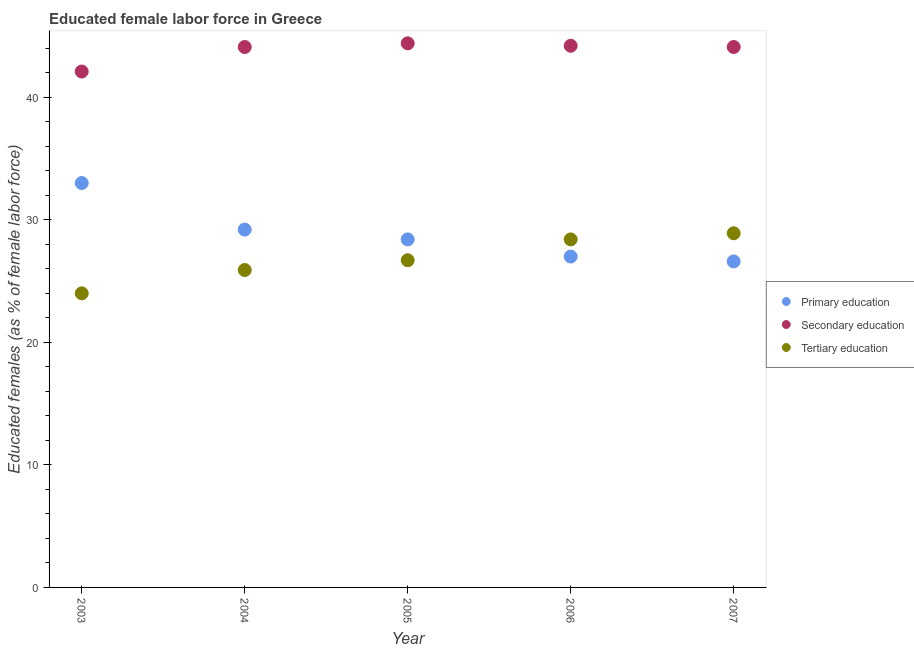How many different coloured dotlines are there?
Provide a succinct answer. 3. Is the number of dotlines equal to the number of legend labels?
Your answer should be very brief. Yes. What is the percentage of female labor force who received tertiary education in 2006?
Your answer should be compact. 28.4. Across all years, what is the maximum percentage of female labor force who received tertiary education?
Your answer should be very brief. 28.9. In which year was the percentage of female labor force who received secondary education maximum?
Offer a terse response. 2005. What is the total percentage of female labor force who received primary education in the graph?
Provide a succinct answer. 144.2. What is the difference between the percentage of female labor force who received primary education in 2003 and that in 2007?
Give a very brief answer. 6.4. What is the difference between the percentage of female labor force who received primary education in 2003 and the percentage of female labor force who received secondary education in 2005?
Provide a succinct answer. -11.4. What is the average percentage of female labor force who received tertiary education per year?
Make the answer very short. 26.78. In the year 2004, what is the difference between the percentage of female labor force who received secondary education and percentage of female labor force who received primary education?
Keep it short and to the point. 14.9. In how many years, is the percentage of female labor force who received tertiary education greater than 20 %?
Your answer should be compact. 5. What is the ratio of the percentage of female labor force who received tertiary education in 2003 to that in 2004?
Give a very brief answer. 0.93. Is the percentage of female labor force who received primary education in 2003 less than that in 2007?
Provide a succinct answer. No. What is the difference between the highest and the second highest percentage of female labor force who received primary education?
Offer a very short reply. 3.8. What is the difference between the highest and the lowest percentage of female labor force who received tertiary education?
Provide a short and direct response. 4.9. In how many years, is the percentage of female labor force who received secondary education greater than the average percentage of female labor force who received secondary education taken over all years?
Provide a short and direct response. 4. Is the sum of the percentage of female labor force who received tertiary education in 2005 and 2007 greater than the maximum percentage of female labor force who received primary education across all years?
Your response must be concise. Yes. Is it the case that in every year, the sum of the percentage of female labor force who received primary education and percentage of female labor force who received secondary education is greater than the percentage of female labor force who received tertiary education?
Give a very brief answer. Yes. Is the percentage of female labor force who received tertiary education strictly greater than the percentage of female labor force who received primary education over the years?
Keep it short and to the point. No. Is the percentage of female labor force who received primary education strictly less than the percentage of female labor force who received secondary education over the years?
Provide a succinct answer. Yes. What is the difference between two consecutive major ticks on the Y-axis?
Make the answer very short. 10. Does the graph contain any zero values?
Provide a short and direct response. No. Does the graph contain grids?
Your answer should be compact. No. Where does the legend appear in the graph?
Offer a very short reply. Center right. How many legend labels are there?
Make the answer very short. 3. What is the title of the graph?
Offer a very short reply. Educated female labor force in Greece. Does "Profit Tax" appear as one of the legend labels in the graph?
Give a very brief answer. No. What is the label or title of the Y-axis?
Make the answer very short. Educated females (as % of female labor force). What is the Educated females (as % of female labor force) of Primary education in 2003?
Your answer should be compact. 33. What is the Educated females (as % of female labor force) of Secondary education in 2003?
Provide a short and direct response. 42.1. What is the Educated females (as % of female labor force) of Tertiary education in 2003?
Offer a terse response. 24. What is the Educated females (as % of female labor force) of Primary education in 2004?
Your answer should be very brief. 29.2. What is the Educated females (as % of female labor force) in Secondary education in 2004?
Keep it short and to the point. 44.1. What is the Educated females (as % of female labor force) of Tertiary education in 2004?
Provide a short and direct response. 25.9. What is the Educated females (as % of female labor force) in Primary education in 2005?
Provide a short and direct response. 28.4. What is the Educated females (as % of female labor force) of Secondary education in 2005?
Provide a short and direct response. 44.4. What is the Educated females (as % of female labor force) of Tertiary education in 2005?
Keep it short and to the point. 26.7. What is the Educated females (as % of female labor force) of Primary education in 2006?
Your response must be concise. 27. What is the Educated females (as % of female labor force) of Secondary education in 2006?
Ensure brevity in your answer.  44.2. What is the Educated females (as % of female labor force) in Tertiary education in 2006?
Provide a succinct answer. 28.4. What is the Educated females (as % of female labor force) in Primary education in 2007?
Your response must be concise. 26.6. What is the Educated females (as % of female labor force) of Secondary education in 2007?
Your answer should be very brief. 44.1. What is the Educated females (as % of female labor force) in Tertiary education in 2007?
Give a very brief answer. 28.9. Across all years, what is the maximum Educated females (as % of female labor force) in Secondary education?
Provide a short and direct response. 44.4. Across all years, what is the maximum Educated females (as % of female labor force) in Tertiary education?
Your response must be concise. 28.9. Across all years, what is the minimum Educated females (as % of female labor force) of Primary education?
Offer a very short reply. 26.6. Across all years, what is the minimum Educated females (as % of female labor force) of Secondary education?
Provide a short and direct response. 42.1. Across all years, what is the minimum Educated females (as % of female labor force) of Tertiary education?
Offer a terse response. 24. What is the total Educated females (as % of female labor force) of Primary education in the graph?
Provide a succinct answer. 144.2. What is the total Educated females (as % of female labor force) of Secondary education in the graph?
Give a very brief answer. 218.9. What is the total Educated females (as % of female labor force) of Tertiary education in the graph?
Keep it short and to the point. 133.9. What is the difference between the Educated females (as % of female labor force) in Primary education in 2003 and that in 2004?
Provide a short and direct response. 3.8. What is the difference between the Educated females (as % of female labor force) in Secondary education in 2003 and that in 2004?
Your response must be concise. -2. What is the difference between the Educated females (as % of female labor force) in Tertiary education in 2003 and that in 2004?
Offer a very short reply. -1.9. What is the difference between the Educated females (as % of female labor force) of Primary education in 2003 and that in 2005?
Ensure brevity in your answer.  4.6. What is the difference between the Educated females (as % of female labor force) of Tertiary education in 2003 and that in 2005?
Provide a succinct answer. -2.7. What is the difference between the Educated females (as % of female labor force) in Secondary education in 2003 and that in 2006?
Your response must be concise. -2.1. What is the difference between the Educated females (as % of female labor force) in Tertiary education in 2003 and that in 2006?
Keep it short and to the point. -4.4. What is the difference between the Educated females (as % of female labor force) in Tertiary education in 2003 and that in 2007?
Make the answer very short. -4.9. What is the difference between the Educated females (as % of female labor force) in Primary education in 2004 and that in 2005?
Give a very brief answer. 0.8. What is the difference between the Educated females (as % of female labor force) of Tertiary education in 2004 and that in 2005?
Make the answer very short. -0.8. What is the difference between the Educated females (as % of female labor force) of Primary education in 2004 and that in 2006?
Make the answer very short. 2.2. What is the difference between the Educated females (as % of female labor force) in Secondary education in 2004 and that in 2006?
Give a very brief answer. -0.1. What is the difference between the Educated females (as % of female labor force) in Tertiary education in 2004 and that in 2007?
Keep it short and to the point. -3. What is the difference between the Educated females (as % of female labor force) of Secondary education in 2005 and that in 2006?
Give a very brief answer. 0.2. What is the difference between the Educated females (as % of female labor force) of Primary education in 2005 and that in 2007?
Your response must be concise. 1.8. What is the difference between the Educated females (as % of female labor force) of Secondary education in 2006 and that in 2007?
Keep it short and to the point. 0.1. What is the difference between the Educated females (as % of female labor force) in Tertiary education in 2006 and that in 2007?
Give a very brief answer. -0.5. What is the difference between the Educated females (as % of female labor force) of Primary education in 2003 and the Educated females (as % of female labor force) of Secondary education in 2004?
Provide a short and direct response. -11.1. What is the difference between the Educated females (as % of female labor force) of Secondary education in 2003 and the Educated females (as % of female labor force) of Tertiary education in 2004?
Make the answer very short. 16.2. What is the difference between the Educated females (as % of female labor force) of Primary education in 2003 and the Educated females (as % of female labor force) of Secondary education in 2005?
Provide a succinct answer. -11.4. What is the difference between the Educated females (as % of female labor force) in Primary education in 2003 and the Educated females (as % of female labor force) in Tertiary education in 2005?
Provide a short and direct response. 6.3. What is the difference between the Educated females (as % of female labor force) of Secondary education in 2003 and the Educated females (as % of female labor force) of Tertiary education in 2005?
Offer a very short reply. 15.4. What is the difference between the Educated females (as % of female labor force) in Primary education in 2003 and the Educated females (as % of female labor force) in Secondary education in 2006?
Your answer should be very brief. -11.2. What is the difference between the Educated females (as % of female labor force) in Primary education in 2003 and the Educated females (as % of female labor force) in Tertiary education in 2006?
Offer a terse response. 4.6. What is the difference between the Educated females (as % of female labor force) of Secondary education in 2003 and the Educated females (as % of female labor force) of Tertiary education in 2006?
Keep it short and to the point. 13.7. What is the difference between the Educated females (as % of female labor force) in Primary education in 2003 and the Educated females (as % of female labor force) in Tertiary education in 2007?
Your answer should be very brief. 4.1. What is the difference between the Educated females (as % of female labor force) of Primary education in 2004 and the Educated females (as % of female labor force) of Secondary education in 2005?
Provide a short and direct response. -15.2. What is the difference between the Educated females (as % of female labor force) in Primary education in 2004 and the Educated females (as % of female labor force) in Tertiary education in 2005?
Keep it short and to the point. 2.5. What is the difference between the Educated females (as % of female labor force) of Primary education in 2004 and the Educated females (as % of female labor force) of Secondary education in 2006?
Keep it short and to the point. -15. What is the difference between the Educated females (as % of female labor force) of Primary education in 2004 and the Educated females (as % of female labor force) of Tertiary education in 2006?
Your response must be concise. 0.8. What is the difference between the Educated females (as % of female labor force) of Secondary education in 2004 and the Educated females (as % of female labor force) of Tertiary education in 2006?
Your answer should be compact. 15.7. What is the difference between the Educated females (as % of female labor force) in Primary education in 2004 and the Educated females (as % of female labor force) in Secondary education in 2007?
Your response must be concise. -14.9. What is the difference between the Educated females (as % of female labor force) of Primary education in 2005 and the Educated females (as % of female labor force) of Secondary education in 2006?
Your answer should be compact. -15.8. What is the difference between the Educated females (as % of female labor force) in Primary education in 2005 and the Educated females (as % of female labor force) in Tertiary education in 2006?
Provide a short and direct response. 0. What is the difference between the Educated females (as % of female labor force) in Primary education in 2005 and the Educated females (as % of female labor force) in Secondary education in 2007?
Give a very brief answer. -15.7. What is the difference between the Educated females (as % of female labor force) of Primary education in 2006 and the Educated females (as % of female labor force) of Secondary education in 2007?
Your answer should be very brief. -17.1. What is the difference between the Educated females (as % of female labor force) of Primary education in 2006 and the Educated females (as % of female labor force) of Tertiary education in 2007?
Offer a terse response. -1.9. What is the average Educated females (as % of female labor force) of Primary education per year?
Provide a short and direct response. 28.84. What is the average Educated females (as % of female labor force) of Secondary education per year?
Give a very brief answer. 43.78. What is the average Educated females (as % of female labor force) in Tertiary education per year?
Ensure brevity in your answer.  26.78. In the year 2004, what is the difference between the Educated females (as % of female labor force) of Primary education and Educated females (as % of female labor force) of Secondary education?
Ensure brevity in your answer.  -14.9. In the year 2004, what is the difference between the Educated females (as % of female labor force) of Primary education and Educated females (as % of female labor force) of Tertiary education?
Keep it short and to the point. 3.3. In the year 2004, what is the difference between the Educated females (as % of female labor force) of Secondary education and Educated females (as % of female labor force) of Tertiary education?
Keep it short and to the point. 18.2. In the year 2005, what is the difference between the Educated females (as % of female labor force) in Primary education and Educated females (as % of female labor force) in Secondary education?
Give a very brief answer. -16. In the year 2005, what is the difference between the Educated females (as % of female labor force) in Primary education and Educated females (as % of female labor force) in Tertiary education?
Your answer should be compact. 1.7. In the year 2006, what is the difference between the Educated females (as % of female labor force) of Primary education and Educated females (as % of female labor force) of Secondary education?
Make the answer very short. -17.2. In the year 2006, what is the difference between the Educated females (as % of female labor force) of Primary education and Educated females (as % of female labor force) of Tertiary education?
Your answer should be very brief. -1.4. In the year 2007, what is the difference between the Educated females (as % of female labor force) in Primary education and Educated females (as % of female labor force) in Secondary education?
Offer a terse response. -17.5. What is the ratio of the Educated females (as % of female labor force) in Primary education in 2003 to that in 2004?
Make the answer very short. 1.13. What is the ratio of the Educated females (as % of female labor force) in Secondary education in 2003 to that in 2004?
Offer a very short reply. 0.95. What is the ratio of the Educated females (as % of female labor force) in Tertiary education in 2003 to that in 2004?
Offer a terse response. 0.93. What is the ratio of the Educated females (as % of female labor force) in Primary education in 2003 to that in 2005?
Your answer should be compact. 1.16. What is the ratio of the Educated females (as % of female labor force) in Secondary education in 2003 to that in 2005?
Your answer should be very brief. 0.95. What is the ratio of the Educated females (as % of female labor force) of Tertiary education in 2003 to that in 2005?
Offer a terse response. 0.9. What is the ratio of the Educated females (as % of female labor force) in Primary education in 2003 to that in 2006?
Offer a terse response. 1.22. What is the ratio of the Educated females (as % of female labor force) of Secondary education in 2003 to that in 2006?
Give a very brief answer. 0.95. What is the ratio of the Educated females (as % of female labor force) in Tertiary education in 2003 to that in 2006?
Ensure brevity in your answer.  0.85. What is the ratio of the Educated females (as % of female labor force) in Primary education in 2003 to that in 2007?
Provide a short and direct response. 1.24. What is the ratio of the Educated females (as % of female labor force) in Secondary education in 2003 to that in 2007?
Make the answer very short. 0.95. What is the ratio of the Educated females (as % of female labor force) in Tertiary education in 2003 to that in 2007?
Offer a terse response. 0.83. What is the ratio of the Educated females (as % of female labor force) in Primary education in 2004 to that in 2005?
Make the answer very short. 1.03. What is the ratio of the Educated females (as % of female labor force) in Primary education in 2004 to that in 2006?
Your answer should be compact. 1.08. What is the ratio of the Educated females (as % of female labor force) of Tertiary education in 2004 to that in 2006?
Your answer should be compact. 0.91. What is the ratio of the Educated females (as % of female labor force) in Primary education in 2004 to that in 2007?
Keep it short and to the point. 1.1. What is the ratio of the Educated females (as % of female labor force) in Secondary education in 2004 to that in 2007?
Ensure brevity in your answer.  1. What is the ratio of the Educated females (as % of female labor force) in Tertiary education in 2004 to that in 2007?
Provide a short and direct response. 0.9. What is the ratio of the Educated females (as % of female labor force) in Primary education in 2005 to that in 2006?
Your response must be concise. 1.05. What is the ratio of the Educated females (as % of female labor force) of Tertiary education in 2005 to that in 2006?
Ensure brevity in your answer.  0.94. What is the ratio of the Educated females (as % of female labor force) of Primary education in 2005 to that in 2007?
Offer a terse response. 1.07. What is the ratio of the Educated females (as % of female labor force) in Secondary education in 2005 to that in 2007?
Offer a very short reply. 1.01. What is the ratio of the Educated females (as % of female labor force) in Tertiary education in 2005 to that in 2007?
Ensure brevity in your answer.  0.92. What is the ratio of the Educated females (as % of female labor force) of Primary education in 2006 to that in 2007?
Your answer should be compact. 1.01. What is the ratio of the Educated females (as % of female labor force) of Tertiary education in 2006 to that in 2007?
Keep it short and to the point. 0.98. What is the difference between the highest and the lowest Educated females (as % of female labor force) in Primary education?
Ensure brevity in your answer.  6.4. What is the difference between the highest and the lowest Educated females (as % of female labor force) in Secondary education?
Give a very brief answer. 2.3. What is the difference between the highest and the lowest Educated females (as % of female labor force) of Tertiary education?
Offer a terse response. 4.9. 